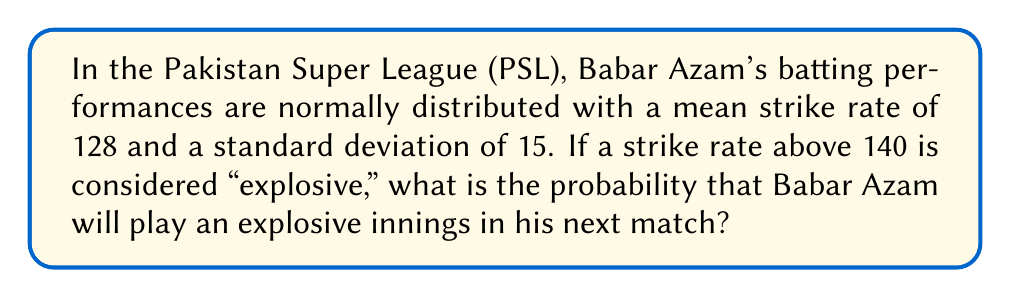Give your solution to this math problem. To solve this problem, we need to use the properties of the normal distribution and calculate the z-score for the given threshold.

Step 1: Identify the given information
- Mean strike rate (μ) = 128
- Standard deviation (σ) = 15
- Threshold for "explosive" innings = 140

Step 2: Calculate the z-score for the threshold
The z-score represents how many standard deviations a value is from the mean.

$$ z = \frac{x - \mu}{\sigma} $$

Where:
x = threshold value
μ = mean
σ = standard deviation

Plugging in the values:

$$ z = \frac{140 - 128}{15} = \frac{12}{15} = 0.8 $$

Step 3: Use the standard normal distribution table or a calculator to find the area to the right of the z-score

The area to the right of z = 0.8 represents the probability of Babar Azam having a strike rate above 140.

Using a standard normal distribution table or calculator, we find:

P(Z > 0.8) ≈ 0.2119

Step 4: Convert the probability to a percentage

0.2119 * 100 ≈ 21.19%

Therefore, there is approximately a 21.19% chance that Babar Azam will play an explosive innings (strike rate above 140) in his next match.
Answer: 21.19% 